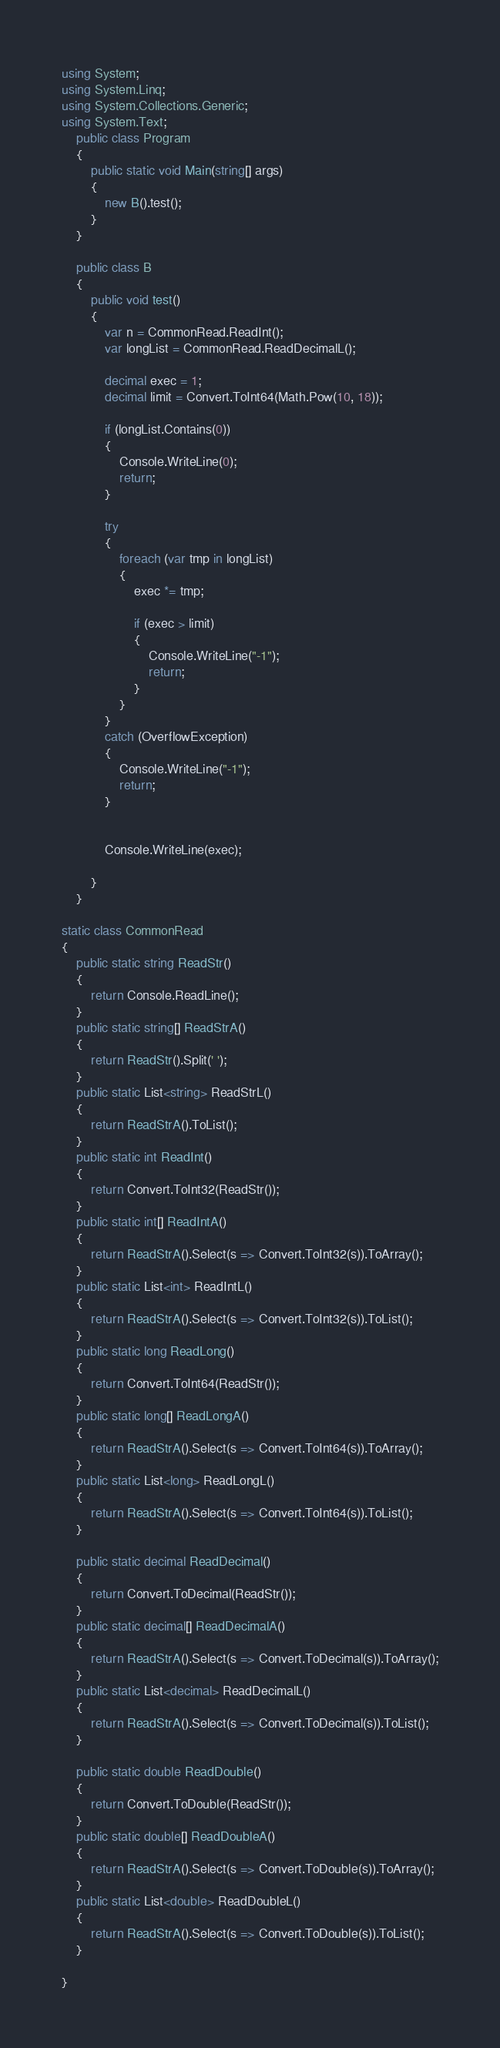<code> <loc_0><loc_0><loc_500><loc_500><_C#_>using System;
using System.Linq;
using System.Collections.Generic;
using System.Text;
    public class Program
    {
        public static void Main(string[] args)
        {
            new B().test();
        }
    }

    public class B
    {
        public void test()
        {
            var n = CommonRead.ReadInt();
            var longList = CommonRead.ReadDecimalL();

            decimal exec = 1;
            decimal limit = Convert.ToInt64(Math.Pow(10, 18));

            if (longList.Contains(0))
            {
                Console.WriteLine(0);
                return;
            }

            try
            {
                foreach (var tmp in longList)
                {
                    exec *= tmp;

                    if (exec > limit)
                    {
                        Console.WriteLine("-1");
                        return;
                    }
                }
            }
            catch (OverflowException)
            {
                Console.WriteLine("-1");
                return;
            }


            Console.WriteLine(exec);

        }
    }

static class CommonRead
{
    public static string ReadStr()
    {
        return Console.ReadLine();
    }
    public static string[] ReadStrA()
    {
        return ReadStr().Split(' ');
    }
    public static List<string> ReadStrL()
    {
        return ReadStrA().ToList();
    }
    public static int ReadInt()
    {
        return Convert.ToInt32(ReadStr());
    }
    public static int[] ReadIntA()
    {
        return ReadStrA().Select(s => Convert.ToInt32(s)).ToArray();
    }
    public static List<int> ReadIntL()
    {
        return ReadStrA().Select(s => Convert.ToInt32(s)).ToList();
    }
    public static long ReadLong()
    {
        return Convert.ToInt64(ReadStr());
    }
    public static long[] ReadLongA()
    {
        return ReadStrA().Select(s => Convert.ToInt64(s)).ToArray();
    }
    public static List<long> ReadLongL()
    {
        return ReadStrA().Select(s => Convert.ToInt64(s)).ToList();
    }

    public static decimal ReadDecimal()
    {
        return Convert.ToDecimal(ReadStr());
    }
    public static decimal[] ReadDecimalA()
    {
        return ReadStrA().Select(s => Convert.ToDecimal(s)).ToArray();
    }
    public static List<decimal> ReadDecimalL()
    {
        return ReadStrA().Select(s => Convert.ToDecimal(s)).ToList();
    }

    public static double ReadDouble()
    {
        return Convert.ToDouble(ReadStr());
    }
    public static double[] ReadDoubleA()
    {
        return ReadStrA().Select(s => Convert.ToDouble(s)).ToArray();
    }
    public static List<double> ReadDoubleL()
    {
        return ReadStrA().Select(s => Convert.ToDouble(s)).ToList();
    }

}
</code> 